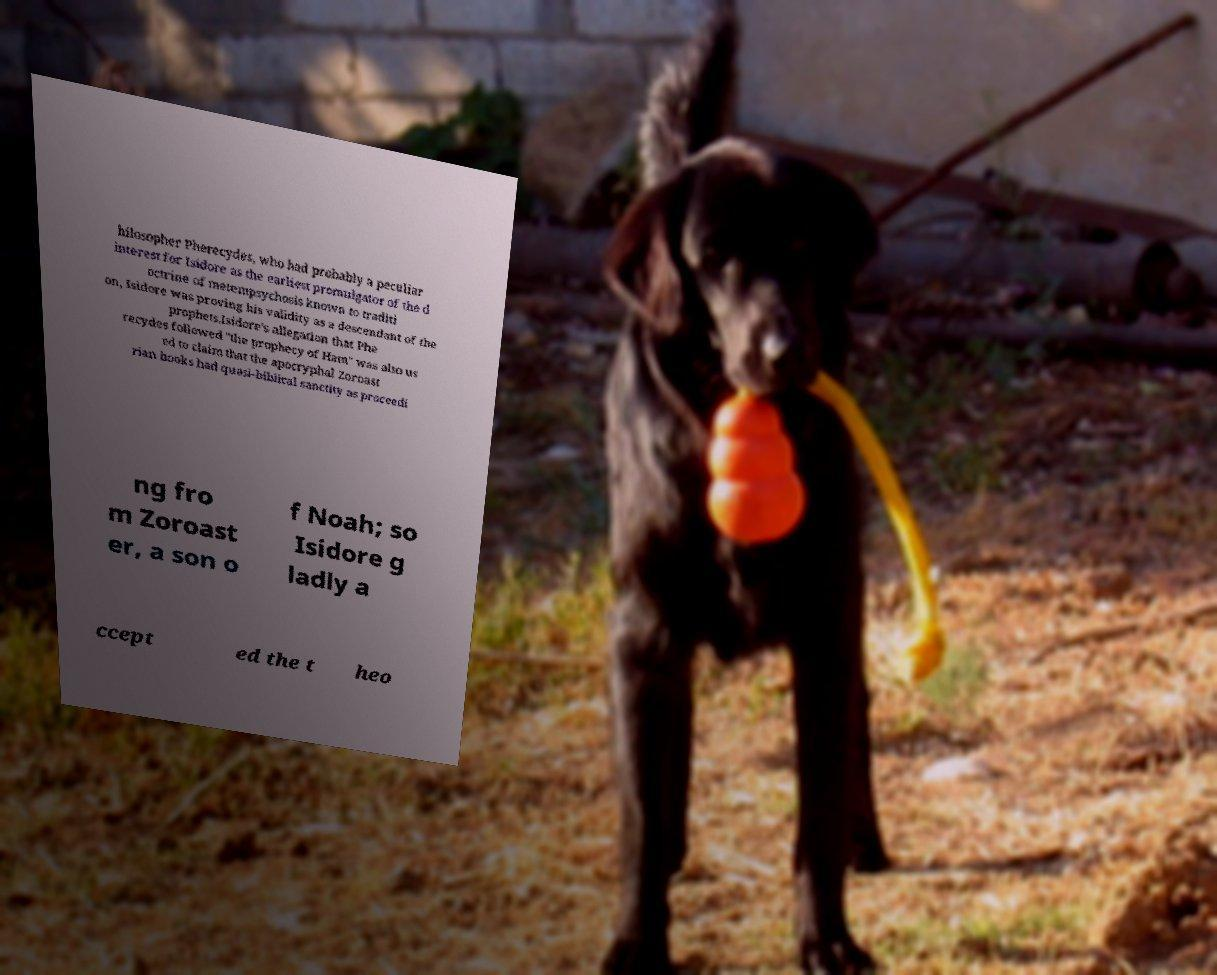I need the written content from this picture converted into text. Can you do that? hilosopher Pherecydes, who had probably a peculiar interest for Isidore as the earliest promulgator of the d octrine of metempsychosis known to traditi on, Isidore was proving his validity as a descendant of the prophets.Isidore's allegation that Phe recydes followed "the prophecy of Ham" was also us ed to claim that the apocryphal Zoroast rian books had quasi-biblical sanctity as proceedi ng fro m Zoroast er, a son o f Noah; so Isidore g ladly a ccept ed the t heo 